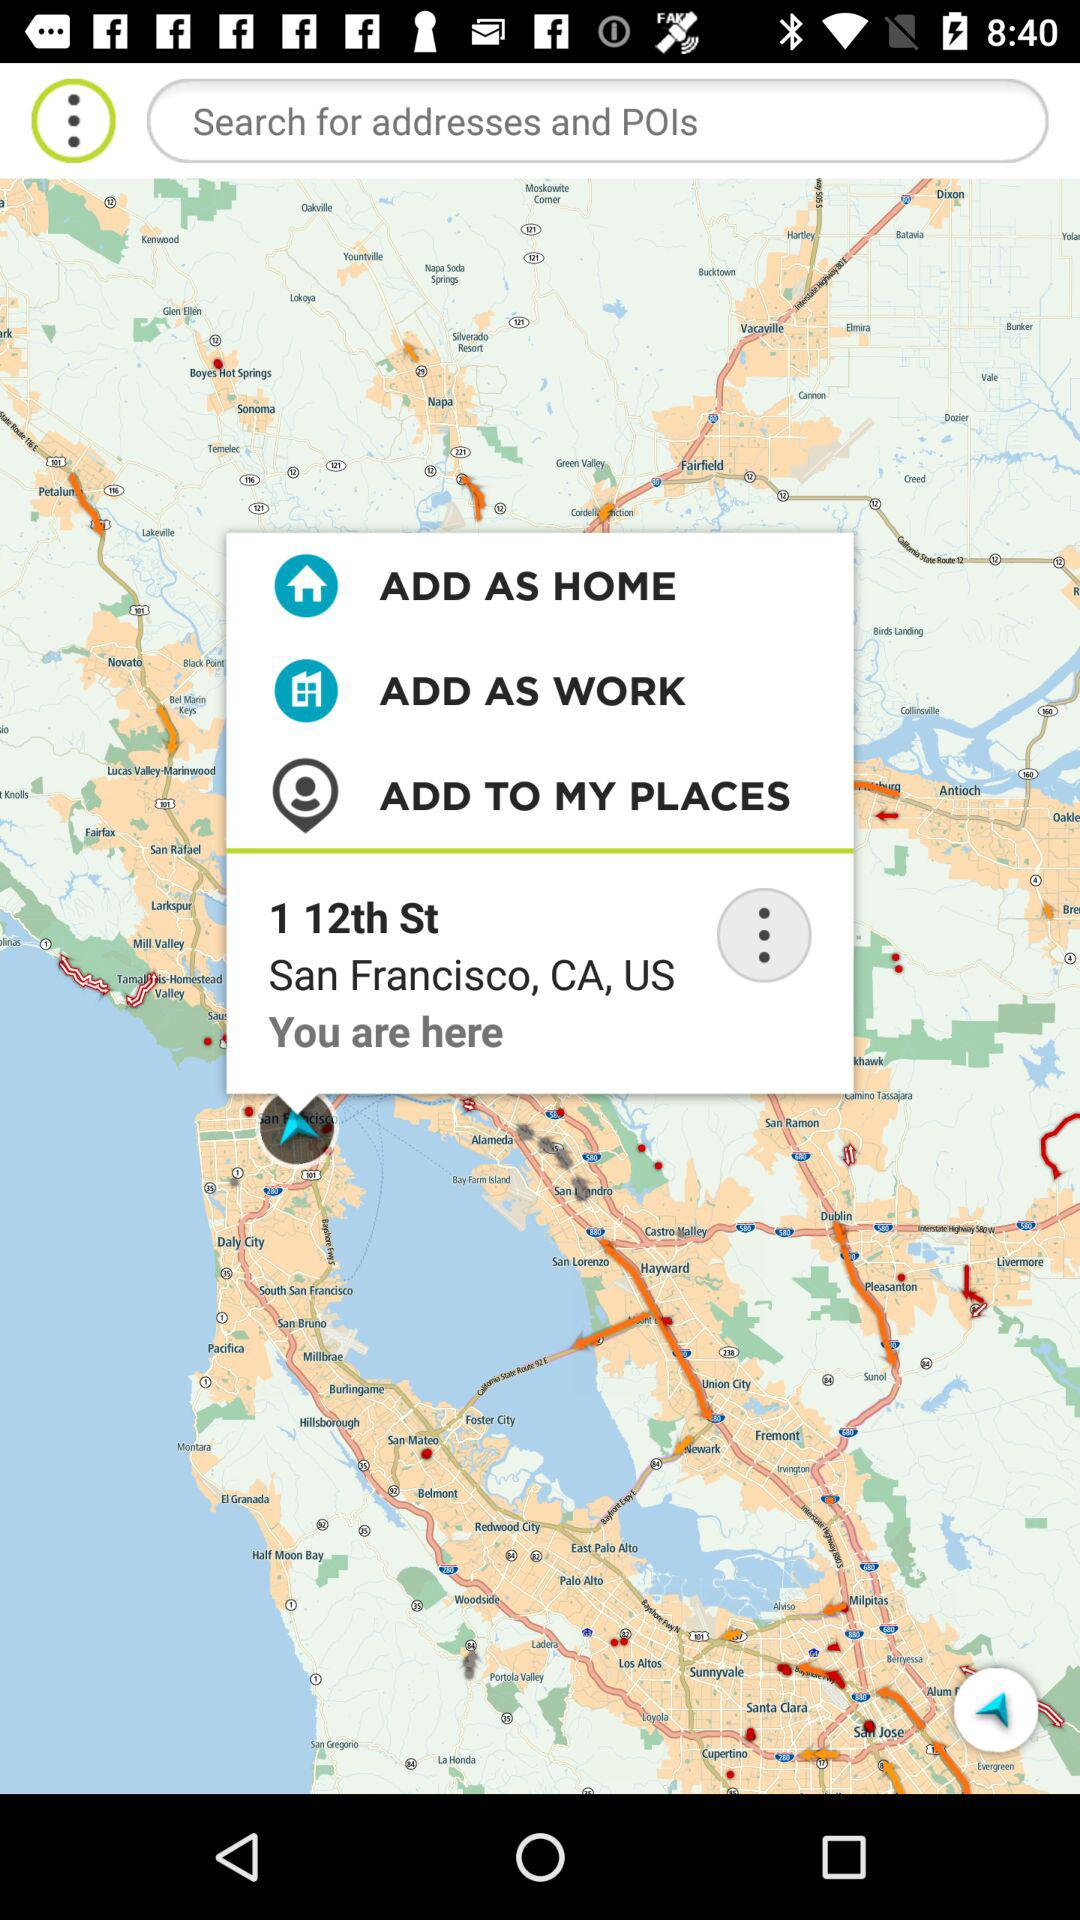What is my current location? Your current location is 1 12th St, San Francisco, CA, US. 